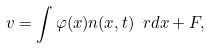Convert formula to latex. <formula><loc_0><loc_0><loc_500><loc_500>v = \int \varphi ( x ) n ( x , t ) \ r d x + F ,</formula> 